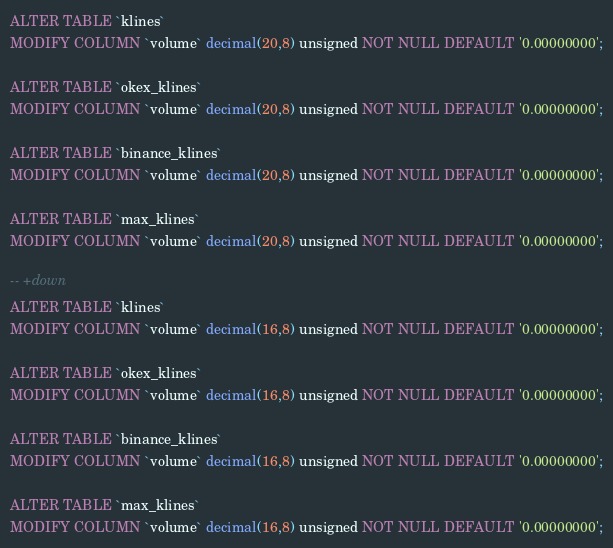Convert code to text. <code><loc_0><loc_0><loc_500><loc_500><_SQL_>ALTER TABLE `klines`
MODIFY COLUMN `volume` decimal(20,8) unsigned NOT NULL DEFAULT '0.00000000';

ALTER TABLE `okex_klines`
MODIFY COLUMN `volume` decimal(20,8) unsigned NOT NULL DEFAULT '0.00000000';

ALTER TABLE `binance_klines`
MODIFY COLUMN `volume` decimal(20,8) unsigned NOT NULL DEFAULT '0.00000000';

ALTER TABLE `max_klines`
MODIFY COLUMN `volume` decimal(20,8) unsigned NOT NULL DEFAULT '0.00000000';

-- +down
ALTER TABLE `klines`
MODIFY COLUMN `volume` decimal(16,8) unsigned NOT NULL DEFAULT '0.00000000';

ALTER TABLE `okex_klines`
MODIFY COLUMN `volume` decimal(16,8) unsigned NOT NULL DEFAULT '0.00000000';

ALTER TABLE `binance_klines`
MODIFY COLUMN `volume` decimal(16,8) unsigned NOT NULL DEFAULT '0.00000000';

ALTER TABLE `max_klines`
MODIFY COLUMN `volume` decimal(16,8) unsigned NOT NULL DEFAULT '0.00000000';
</code> 